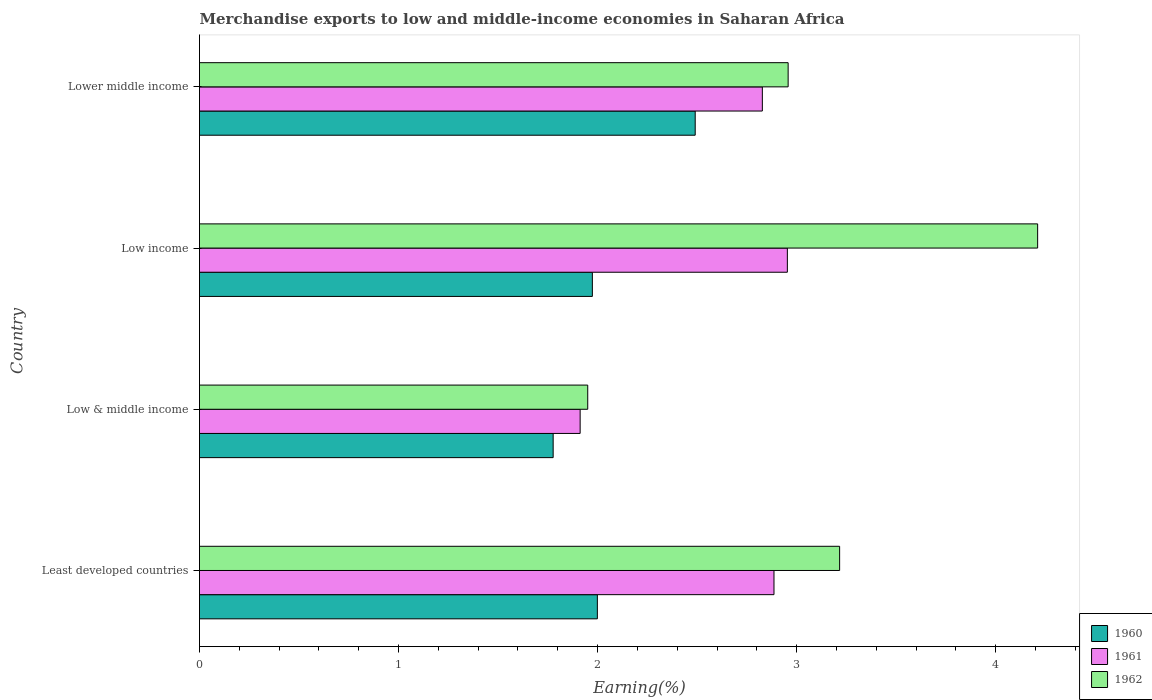How many groups of bars are there?
Give a very brief answer. 4. Are the number of bars on each tick of the Y-axis equal?
Your answer should be compact. Yes. How many bars are there on the 2nd tick from the top?
Make the answer very short. 3. How many bars are there on the 3rd tick from the bottom?
Offer a terse response. 3. What is the label of the 4th group of bars from the top?
Make the answer very short. Least developed countries. In how many cases, is the number of bars for a given country not equal to the number of legend labels?
Offer a very short reply. 0. What is the percentage of amount earned from merchandise exports in 1962 in Lower middle income?
Offer a terse response. 2.96. Across all countries, what is the maximum percentage of amount earned from merchandise exports in 1961?
Offer a terse response. 2.95. Across all countries, what is the minimum percentage of amount earned from merchandise exports in 1960?
Make the answer very short. 1.78. In which country was the percentage of amount earned from merchandise exports in 1961 minimum?
Ensure brevity in your answer.  Low & middle income. What is the total percentage of amount earned from merchandise exports in 1962 in the graph?
Ensure brevity in your answer.  12.34. What is the difference between the percentage of amount earned from merchandise exports in 1960 in Low & middle income and that in Lower middle income?
Offer a very short reply. -0.71. What is the difference between the percentage of amount earned from merchandise exports in 1962 in Lower middle income and the percentage of amount earned from merchandise exports in 1960 in Low income?
Offer a very short reply. 0.98. What is the average percentage of amount earned from merchandise exports in 1961 per country?
Your response must be concise. 2.65. What is the difference between the percentage of amount earned from merchandise exports in 1960 and percentage of amount earned from merchandise exports in 1962 in Least developed countries?
Offer a very short reply. -1.22. In how many countries, is the percentage of amount earned from merchandise exports in 1961 greater than 2 %?
Keep it short and to the point. 3. What is the ratio of the percentage of amount earned from merchandise exports in 1960 in Low income to that in Lower middle income?
Offer a terse response. 0.79. Is the difference between the percentage of amount earned from merchandise exports in 1960 in Least developed countries and Low income greater than the difference between the percentage of amount earned from merchandise exports in 1962 in Least developed countries and Low income?
Your answer should be very brief. Yes. What is the difference between the highest and the second highest percentage of amount earned from merchandise exports in 1960?
Provide a succinct answer. 0.49. What is the difference between the highest and the lowest percentage of amount earned from merchandise exports in 1962?
Offer a terse response. 2.26. In how many countries, is the percentage of amount earned from merchandise exports in 1962 greater than the average percentage of amount earned from merchandise exports in 1962 taken over all countries?
Give a very brief answer. 2. Is it the case that in every country, the sum of the percentage of amount earned from merchandise exports in 1962 and percentage of amount earned from merchandise exports in 1961 is greater than the percentage of amount earned from merchandise exports in 1960?
Your answer should be compact. Yes. Are all the bars in the graph horizontal?
Offer a very short reply. Yes. How many countries are there in the graph?
Keep it short and to the point. 4. What is the difference between two consecutive major ticks on the X-axis?
Your answer should be compact. 1. Are the values on the major ticks of X-axis written in scientific E-notation?
Your response must be concise. No. Does the graph contain any zero values?
Provide a short and direct response. No. Does the graph contain grids?
Your answer should be compact. No. Where does the legend appear in the graph?
Your answer should be very brief. Bottom right. How many legend labels are there?
Provide a succinct answer. 3. What is the title of the graph?
Give a very brief answer. Merchandise exports to low and middle-income economies in Saharan Africa. Does "1993" appear as one of the legend labels in the graph?
Offer a terse response. No. What is the label or title of the X-axis?
Make the answer very short. Earning(%). What is the Earning(%) of 1960 in Least developed countries?
Offer a very short reply. 2. What is the Earning(%) of 1961 in Least developed countries?
Provide a succinct answer. 2.89. What is the Earning(%) of 1962 in Least developed countries?
Your answer should be compact. 3.22. What is the Earning(%) of 1960 in Low & middle income?
Your answer should be compact. 1.78. What is the Earning(%) of 1961 in Low & middle income?
Make the answer very short. 1.91. What is the Earning(%) of 1962 in Low & middle income?
Your response must be concise. 1.95. What is the Earning(%) in 1960 in Low income?
Keep it short and to the point. 1.97. What is the Earning(%) of 1961 in Low income?
Your response must be concise. 2.95. What is the Earning(%) in 1962 in Low income?
Your answer should be very brief. 4.21. What is the Earning(%) in 1960 in Lower middle income?
Keep it short and to the point. 2.49. What is the Earning(%) in 1961 in Lower middle income?
Ensure brevity in your answer.  2.83. What is the Earning(%) in 1962 in Lower middle income?
Offer a very short reply. 2.96. Across all countries, what is the maximum Earning(%) of 1960?
Provide a short and direct response. 2.49. Across all countries, what is the maximum Earning(%) in 1961?
Your answer should be compact. 2.95. Across all countries, what is the maximum Earning(%) in 1962?
Ensure brevity in your answer.  4.21. Across all countries, what is the minimum Earning(%) in 1960?
Your answer should be very brief. 1.78. Across all countries, what is the minimum Earning(%) of 1961?
Offer a terse response. 1.91. Across all countries, what is the minimum Earning(%) of 1962?
Make the answer very short. 1.95. What is the total Earning(%) of 1960 in the graph?
Keep it short and to the point. 8.24. What is the total Earning(%) in 1961 in the graph?
Your response must be concise. 10.58. What is the total Earning(%) in 1962 in the graph?
Offer a terse response. 12.34. What is the difference between the Earning(%) in 1960 in Least developed countries and that in Low & middle income?
Your answer should be very brief. 0.22. What is the difference between the Earning(%) of 1961 in Least developed countries and that in Low & middle income?
Your response must be concise. 0.97. What is the difference between the Earning(%) in 1962 in Least developed countries and that in Low & middle income?
Provide a short and direct response. 1.27. What is the difference between the Earning(%) in 1960 in Least developed countries and that in Low income?
Ensure brevity in your answer.  0.03. What is the difference between the Earning(%) of 1961 in Least developed countries and that in Low income?
Provide a succinct answer. -0.07. What is the difference between the Earning(%) in 1962 in Least developed countries and that in Low income?
Provide a succinct answer. -0.99. What is the difference between the Earning(%) in 1960 in Least developed countries and that in Lower middle income?
Ensure brevity in your answer.  -0.49. What is the difference between the Earning(%) in 1961 in Least developed countries and that in Lower middle income?
Give a very brief answer. 0.06. What is the difference between the Earning(%) in 1962 in Least developed countries and that in Lower middle income?
Your response must be concise. 0.26. What is the difference between the Earning(%) in 1960 in Low & middle income and that in Low income?
Your answer should be very brief. -0.2. What is the difference between the Earning(%) of 1961 in Low & middle income and that in Low income?
Offer a very short reply. -1.04. What is the difference between the Earning(%) of 1962 in Low & middle income and that in Low income?
Your response must be concise. -2.26. What is the difference between the Earning(%) in 1960 in Low & middle income and that in Lower middle income?
Offer a very short reply. -0.71. What is the difference between the Earning(%) in 1961 in Low & middle income and that in Lower middle income?
Provide a short and direct response. -0.92. What is the difference between the Earning(%) of 1962 in Low & middle income and that in Lower middle income?
Your answer should be compact. -1.01. What is the difference between the Earning(%) of 1960 in Low income and that in Lower middle income?
Give a very brief answer. -0.52. What is the difference between the Earning(%) of 1961 in Low income and that in Lower middle income?
Keep it short and to the point. 0.13. What is the difference between the Earning(%) of 1962 in Low income and that in Lower middle income?
Provide a succinct answer. 1.25. What is the difference between the Earning(%) in 1960 in Least developed countries and the Earning(%) in 1961 in Low & middle income?
Provide a succinct answer. 0.09. What is the difference between the Earning(%) in 1960 in Least developed countries and the Earning(%) in 1962 in Low & middle income?
Give a very brief answer. 0.05. What is the difference between the Earning(%) of 1961 in Least developed countries and the Earning(%) of 1962 in Low & middle income?
Your answer should be very brief. 0.94. What is the difference between the Earning(%) of 1960 in Least developed countries and the Earning(%) of 1961 in Low income?
Offer a very short reply. -0.95. What is the difference between the Earning(%) of 1960 in Least developed countries and the Earning(%) of 1962 in Low income?
Your response must be concise. -2.21. What is the difference between the Earning(%) of 1961 in Least developed countries and the Earning(%) of 1962 in Low income?
Provide a short and direct response. -1.32. What is the difference between the Earning(%) of 1960 in Least developed countries and the Earning(%) of 1961 in Lower middle income?
Provide a succinct answer. -0.83. What is the difference between the Earning(%) of 1960 in Least developed countries and the Earning(%) of 1962 in Lower middle income?
Your answer should be compact. -0.96. What is the difference between the Earning(%) in 1961 in Least developed countries and the Earning(%) in 1962 in Lower middle income?
Make the answer very short. -0.07. What is the difference between the Earning(%) of 1960 in Low & middle income and the Earning(%) of 1961 in Low income?
Make the answer very short. -1.18. What is the difference between the Earning(%) of 1960 in Low & middle income and the Earning(%) of 1962 in Low income?
Your answer should be very brief. -2.43. What is the difference between the Earning(%) in 1961 in Low & middle income and the Earning(%) in 1962 in Low income?
Your answer should be very brief. -2.3. What is the difference between the Earning(%) in 1960 in Low & middle income and the Earning(%) in 1961 in Lower middle income?
Keep it short and to the point. -1.05. What is the difference between the Earning(%) in 1960 in Low & middle income and the Earning(%) in 1962 in Lower middle income?
Give a very brief answer. -1.18. What is the difference between the Earning(%) of 1961 in Low & middle income and the Earning(%) of 1962 in Lower middle income?
Your response must be concise. -1.05. What is the difference between the Earning(%) in 1960 in Low income and the Earning(%) in 1961 in Lower middle income?
Offer a very short reply. -0.85. What is the difference between the Earning(%) in 1960 in Low income and the Earning(%) in 1962 in Lower middle income?
Offer a very short reply. -0.98. What is the difference between the Earning(%) of 1961 in Low income and the Earning(%) of 1962 in Lower middle income?
Your response must be concise. -0. What is the average Earning(%) in 1960 per country?
Ensure brevity in your answer.  2.06. What is the average Earning(%) in 1961 per country?
Make the answer very short. 2.65. What is the average Earning(%) in 1962 per country?
Your answer should be compact. 3.08. What is the difference between the Earning(%) in 1960 and Earning(%) in 1961 in Least developed countries?
Your answer should be very brief. -0.89. What is the difference between the Earning(%) of 1960 and Earning(%) of 1962 in Least developed countries?
Make the answer very short. -1.22. What is the difference between the Earning(%) of 1961 and Earning(%) of 1962 in Least developed countries?
Ensure brevity in your answer.  -0.33. What is the difference between the Earning(%) of 1960 and Earning(%) of 1961 in Low & middle income?
Make the answer very short. -0.14. What is the difference between the Earning(%) of 1960 and Earning(%) of 1962 in Low & middle income?
Provide a succinct answer. -0.17. What is the difference between the Earning(%) of 1961 and Earning(%) of 1962 in Low & middle income?
Provide a short and direct response. -0.04. What is the difference between the Earning(%) in 1960 and Earning(%) in 1961 in Low income?
Ensure brevity in your answer.  -0.98. What is the difference between the Earning(%) in 1960 and Earning(%) in 1962 in Low income?
Your answer should be compact. -2.24. What is the difference between the Earning(%) of 1961 and Earning(%) of 1962 in Low income?
Your answer should be compact. -1.26. What is the difference between the Earning(%) in 1960 and Earning(%) in 1961 in Lower middle income?
Your response must be concise. -0.34. What is the difference between the Earning(%) of 1960 and Earning(%) of 1962 in Lower middle income?
Provide a short and direct response. -0.47. What is the difference between the Earning(%) of 1961 and Earning(%) of 1962 in Lower middle income?
Make the answer very short. -0.13. What is the ratio of the Earning(%) of 1961 in Least developed countries to that in Low & middle income?
Make the answer very short. 1.51. What is the ratio of the Earning(%) in 1962 in Least developed countries to that in Low & middle income?
Make the answer very short. 1.65. What is the ratio of the Earning(%) in 1960 in Least developed countries to that in Low income?
Ensure brevity in your answer.  1.01. What is the ratio of the Earning(%) in 1961 in Least developed countries to that in Low income?
Offer a terse response. 0.98. What is the ratio of the Earning(%) of 1962 in Least developed countries to that in Low income?
Your answer should be compact. 0.76. What is the ratio of the Earning(%) of 1960 in Least developed countries to that in Lower middle income?
Make the answer very short. 0.8. What is the ratio of the Earning(%) of 1961 in Least developed countries to that in Lower middle income?
Keep it short and to the point. 1.02. What is the ratio of the Earning(%) of 1962 in Least developed countries to that in Lower middle income?
Your response must be concise. 1.09. What is the ratio of the Earning(%) of 1960 in Low & middle income to that in Low income?
Ensure brevity in your answer.  0.9. What is the ratio of the Earning(%) in 1961 in Low & middle income to that in Low income?
Give a very brief answer. 0.65. What is the ratio of the Earning(%) of 1962 in Low & middle income to that in Low income?
Your answer should be compact. 0.46. What is the ratio of the Earning(%) in 1960 in Low & middle income to that in Lower middle income?
Ensure brevity in your answer.  0.71. What is the ratio of the Earning(%) of 1961 in Low & middle income to that in Lower middle income?
Your response must be concise. 0.68. What is the ratio of the Earning(%) of 1962 in Low & middle income to that in Lower middle income?
Provide a short and direct response. 0.66. What is the ratio of the Earning(%) in 1960 in Low income to that in Lower middle income?
Your answer should be very brief. 0.79. What is the ratio of the Earning(%) of 1961 in Low income to that in Lower middle income?
Ensure brevity in your answer.  1.04. What is the ratio of the Earning(%) in 1962 in Low income to that in Lower middle income?
Keep it short and to the point. 1.42. What is the difference between the highest and the second highest Earning(%) in 1960?
Your answer should be compact. 0.49. What is the difference between the highest and the second highest Earning(%) of 1961?
Offer a very short reply. 0.07. What is the difference between the highest and the second highest Earning(%) of 1962?
Offer a very short reply. 0.99. What is the difference between the highest and the lowest Earning(%) in 1960?
Provide a short and direct response. 0.71. What is the difference between the highest and the lowest Earning(%) in 1961?
Offer a terse response. 1.04. What is the difference between the highest and the lowest Earning(%) of 1962?
Provide a succinct answer. 2.26. 